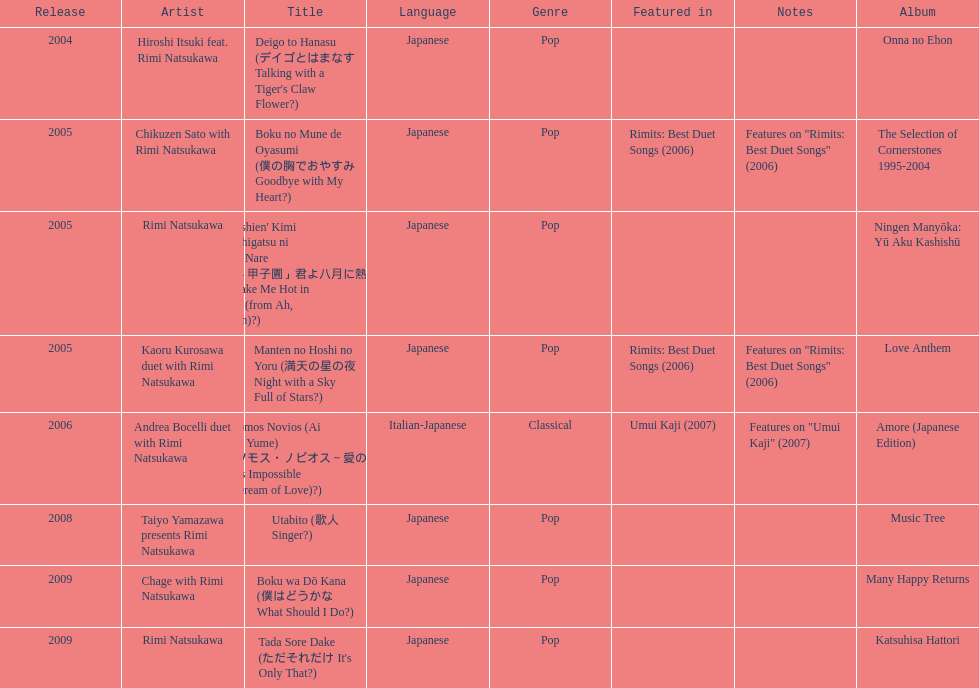What is the number of albums released with the artist rimi natsukawa? 8. 